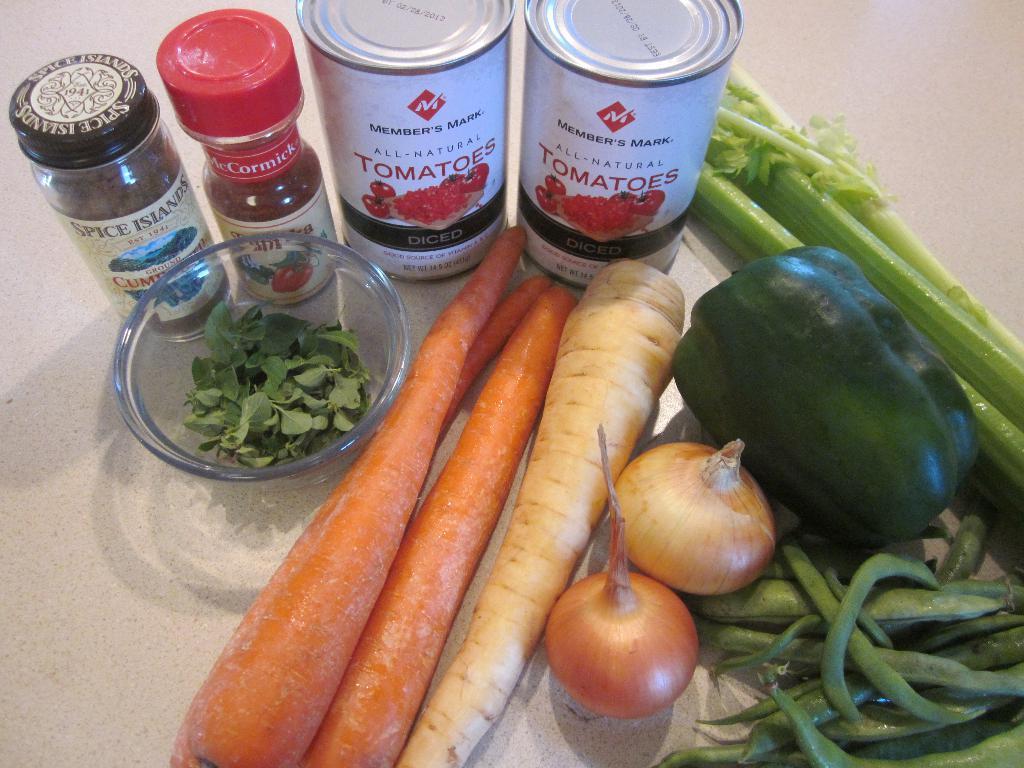Describe this image in one or two sentences. In this image we can see group of vegetables placed on the surface, some leaves are placed in the bowl. In the background, we can see two metal containers and bottles placed on the surface. 